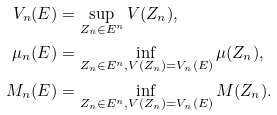<formula> <loc_0><loc_0><loc_500><loc_500>V _ { n } ( E ) & = \sup _ { Z _ { n } \in E ^ { n } } V ( Z _ { n } ) , \\ \mu _ { n } ( E ) & = \inf _ { Z _ { n } \in E ^ { n } , V ( Z _ { n } ) = V _ { n } ( E ) } \mu ( Z _ { n } ) , \\ M _ { n } ( E ) & = \inf _ { Z _ { n } \in E ^ { n } , V ( Z _ { n } ) = V _ { n } ( E ) } M ( Z _ { n } ) .</formula> 